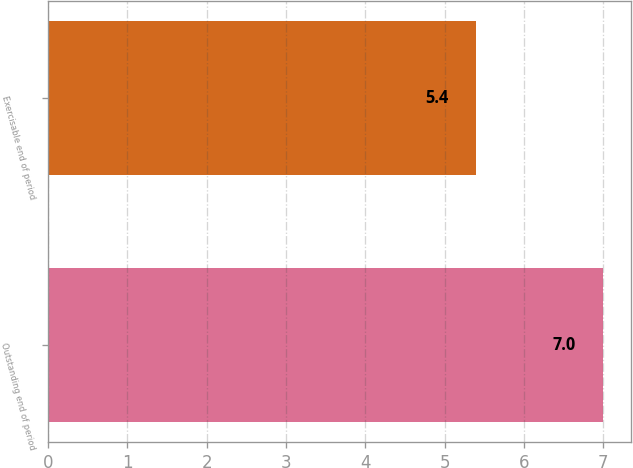<chart> <loc_0><loc_0><loc_500><loc_500><bar_chart><fcel>Outstanding end of period<fcel>Exercisable end of period<nl><fcel>7<fcel>5.4<nl></chart> 